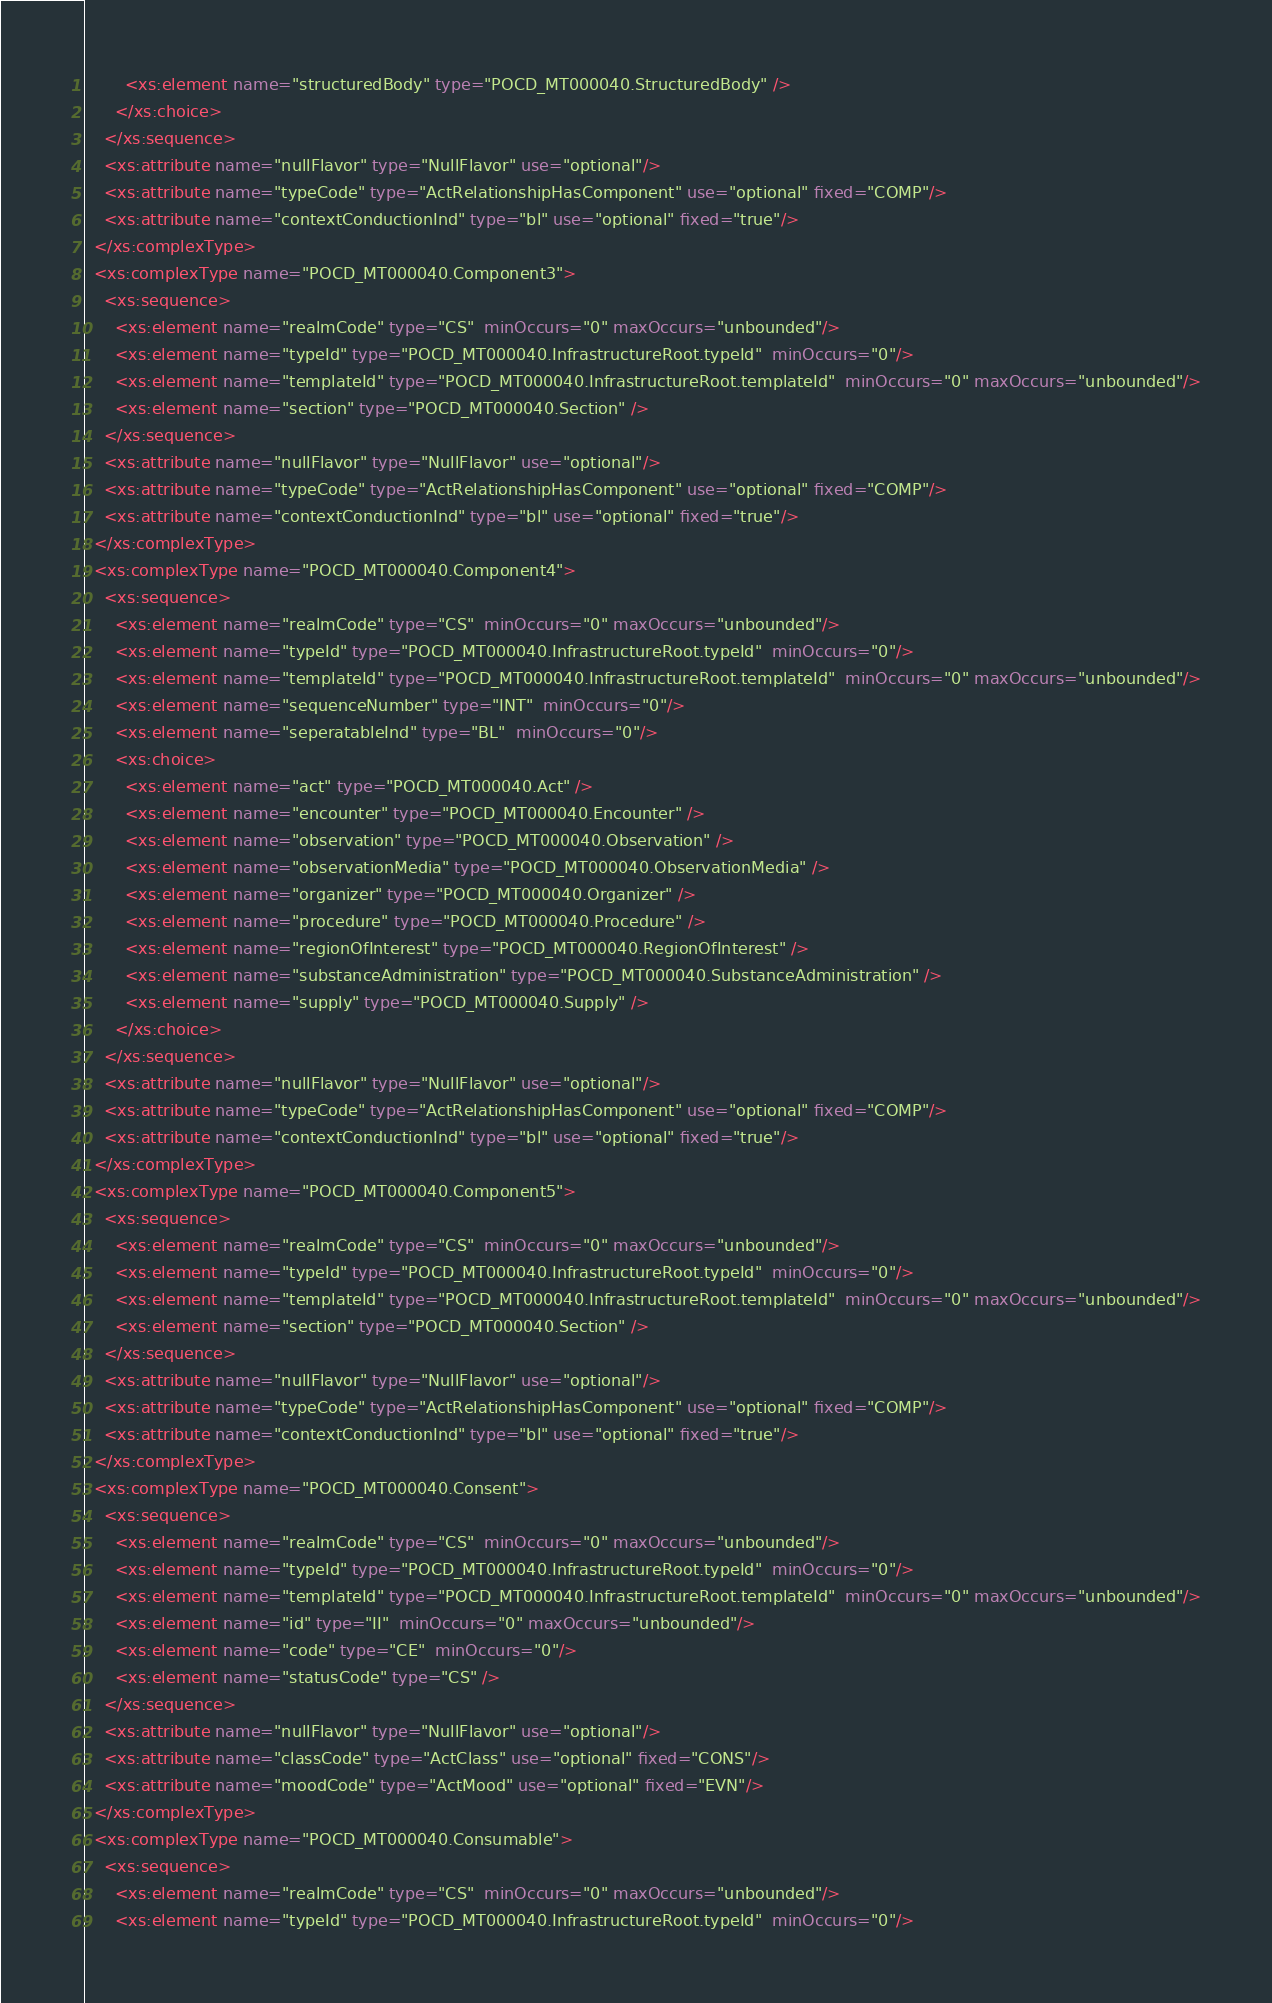<code> <loc_0><loc_0><loc_500><loc_500><_XML_>        <xs:element name="structuredBody" type="POCD_MT000040.StructuredBody" />
      </xs:choice>
    </xs:sequence>
    <xs:attribute name="nullFlavor" type="NullFlavor" use="optional"/>
    <xs:attribute name="typeCode" type="ActRelationshipHasComponent" use="optional" fixed="COMP"/>
    <xs:attribute name="contextConductionInd" type="bl" use="optional" fixed="true"/>
  </xs:complexType>
  <xs:complexType name="POCD_MT000040.Component3">
    <xs:sequence>
      <xs:element name="realmCode" type="CS"  minOccurs="0" maxOccurs="unbounded"/>
      <xs:element name="typeId" type="POCD_MT000040.InfrastructureRoot.typeId"  minOccurs="0"/>
      <xs:element name="templateId" type="POCD_MT000040.InfrastructureRoot.templateId"  minOccurs="0" maxOccurs="unbounded"/>
      <xs:element name="section" type="POCD_MT000040.Section" />
    </xs:sequence>
    <xs:attribute name="nullFlavor" type="NullFlavor" use="optional"/>
    <xs:attribute name="typeCode" type="ActRelationshipHasComponent" use="optional" fixed="COMP"/>
    <xs:attribute name="contextConductionInd" type="bl" use="optional" fixed="true"/>
  </xs:complexType>
  <xs:complexType name="POCD_MT000040.Component4">
    <xs:sequence>
      <xs:element name="realmCode" type="CS"  minOccurs="0" maxOccurs="unbounded"/>
      <xs:element name="typeId" type="POCD_MT000040.InfrastructureRoot.typeId"  minOccurs="0"/>
      <xs:element name="templateId" type="POCD_MT000040.InfrastructureRoot.templateId"  minOccurs="0" maxOccurs="unbounded"/>
      <xs:element name="sequenceNumber" type="INT"  minOccurs="0"/>
      <xs:element name="seperatableInd" type="BL"  minOccurs="0"/>
      <xs:choice>
        <xs:element name="act" type="POCD_MT000040.Act" />
        <xs:element name="encounter" type="POCD_MT000040.Encounter" />
        <xs:element name="observation" type="POCD_MT000040.Observation" />
        <xs:element name="observationMedia" type="POCD_MT000040.ObservationMedia" />
        <xs:element name="organizer" type="POCD_MT000040.Organizer" />
        <xs:element name="procedure" type="POCD_MT000040.Procedure" />
        <xs:element name="regionOfInterest" type="POCD_MT000040.RegionOfInterest" />
        <xs:element name="substanceAdministration" type="POCD_MT000040.SubstanceAdministration" />
        <xs:element name="supply" type="POCD_MT000040.Supply" />
      </xs:choice>
    </xs:sequence>
    <xs:attribute name="nullFlavor" type="NullFlavor" use="optional"/>
    <xs:attribute name="typeCode" type="ActRelationshipHasComponent" use="optional" fixed="COMP"/>
    <xs:attribute name="contextConductionInd" type="bl" use="optional" fixed="true"/>
  </xs:complexType>
  <xs:complexType name="POCD_MT000040.Component5">
    <xs:sequence>
      <xs:element name="realmCode" type="CS"  minOccurs="0" maxOccurs="unbounded"/>
      <xs:element name="typeId" type="POCD_MT000040.InfrastructureRoot.typeId"  minOccurs="0"/>
      <xs:element name="templateId" type="POCD_MT000040.InfrastructureRoot.templateId"  minOccurs="0" maxOccurs="unbounded"/>
      <xs:element name="section" type="POCD_MT000040.Section" />
    </xs:sequence>
    <xs:attribute name="nullFlavor" type="NullFlavor" use="optional"/>
    <xs:attribute name="typeCode" type="ActRelationshipHasComponent" use="optional" fixed="COMP"/>
    <xs:attribute name="contextConductionInd" type="bl" use="optional" fixed="true"/>
  </xs:complexType>
  <xs:complexType name="POCD_MT000040.Consent">
    <xs:sequence>
      <xs:element name="realmCode" type="CS"  minOccurs="0" maxOccurs="unbounded"/>
      <xs:element name="typeId" type="POCD_MT000040.InfrastructureRoot.typeId"  minOccurs="0"/>
      <xs:element name="templateId" type="POCD_MT000040.InfrastructureRoot.templateId"  minOccurs="0" maxOccurs="unbounded"/>
      <xs:element name="id" type="II"  minOccurs="0" maxOccurs="unbounded"/>
      <xs:element name="code" type="CE"  minOccurs="0"/>
      <xs:element name="statusCode" type="CS" />
    </xs:sequence>
    <xs:attribute name="nullFlavor" type="NullFlavor" use="optional"/>
    <xs:attribute name="classCode" type="ActClass" use="optional" fixed="CONS"/>
    <xs:attribute name="moodCode" type="ActMood" use="optional" fixed="EVN"/>
  </xs:complexType>
  <xs:complexType name="POCD_MT000040.Consumable">
    <xs:sequence>
      <xs:element name="realmCode" type="CS"  minOccurs="0" maxOccurs="unbounded"/>
      <xs:element name="typeId" type="POCD_MT000040.InfrastructureRoot.typeId"  minOccurs="0"/></code> 